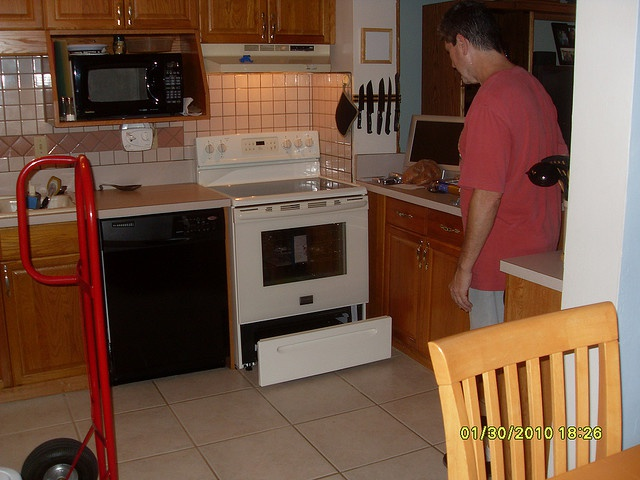Describe the objects in this image and their specific colors. I can see oven in brown, darkgray, black, and gray tones, chair in brown, orange, maroon, and khaki tones, people in brown, maroon, black, and gray tones, refrigerator in brown, black, gray, and maroon tones, and microwave in brown, black, maroon, and gray tones in this image. 